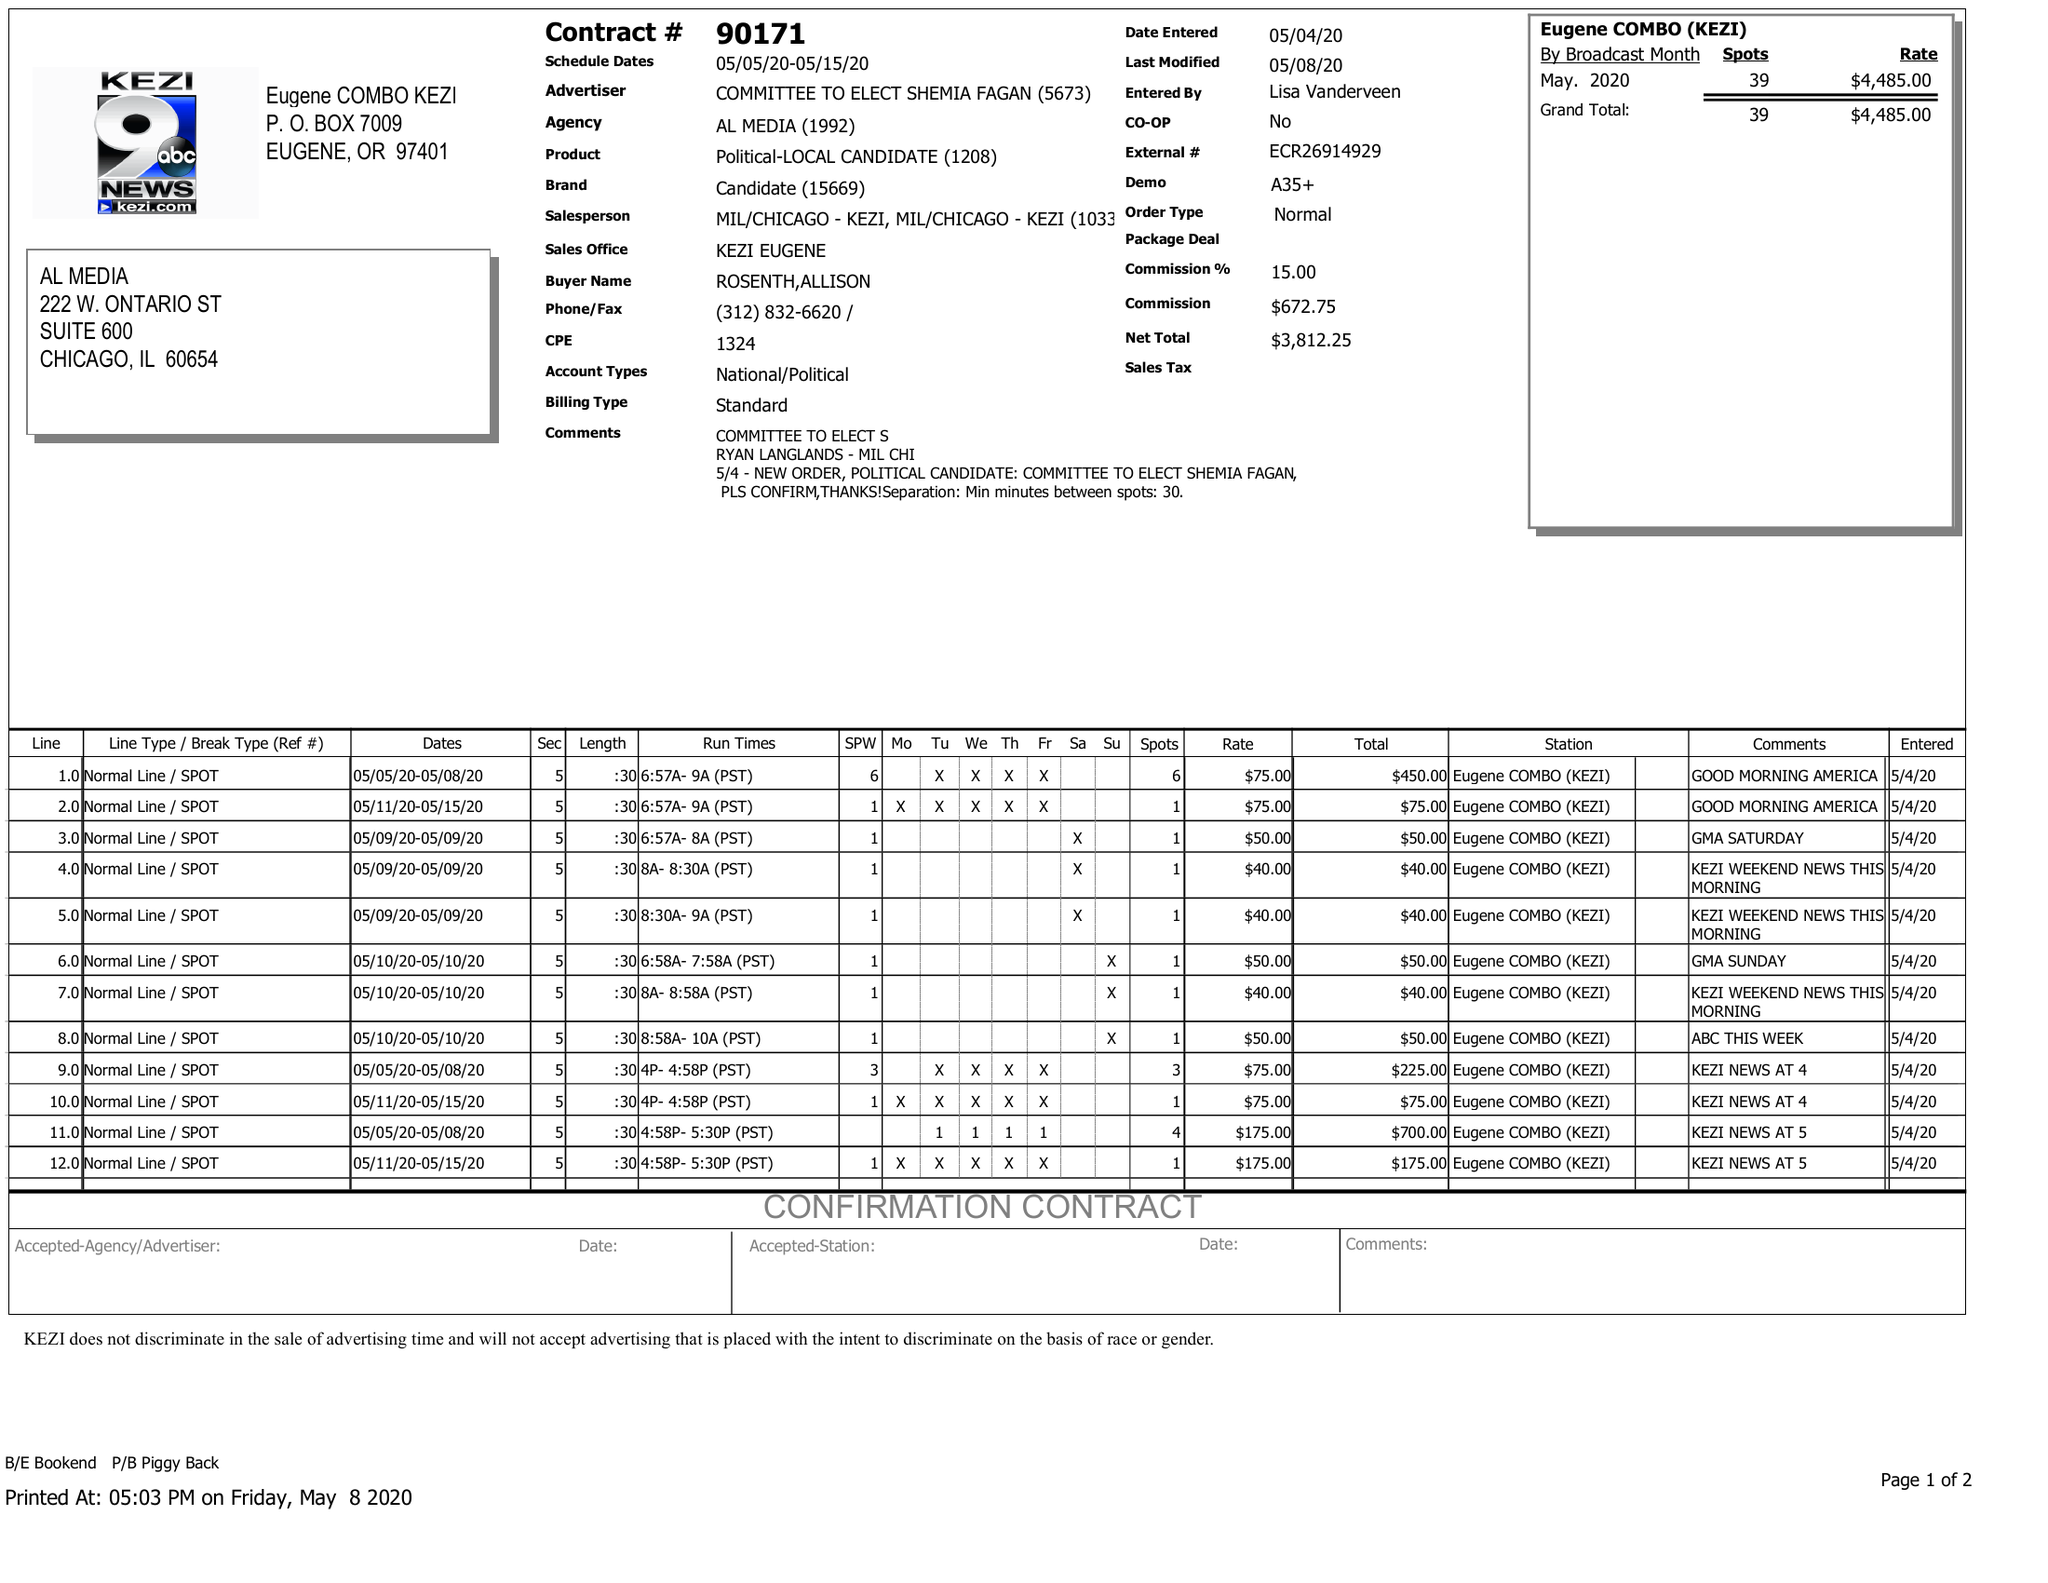What is the value for the contract_num?
Answer the question using a single word or phrase. 90171 